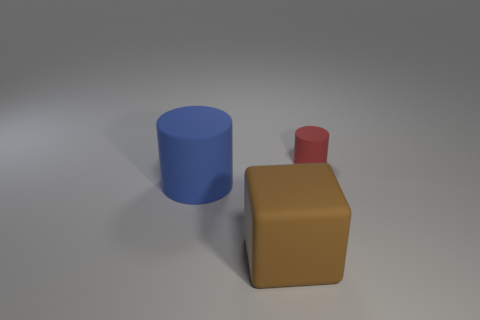What size is the rubber cylinder that is in front of the cylinder behind the big rubber object behind the block?
Give a very brief answer. Large. What number of small things are in front of the matte cylinder that is left of the tiny matte cylinder?
Ensure brevity in your answer.  0. What is the color of the other small thing that is made of the same material as the brown object?
Ensure brevity in your answer.  Red. There is a brown rubber thing that is the same size as the blue cylinder; what shape is it?
Your answer should be compact. Cube. Is the material of the large blue thing the same as the cylinder that is right of the large brown block?
Your answer should be compact. Yes. What number of other objects are there of the same material as the big block?
Keep it short and to the point. 2. There is a cylinder behind the rubber object on the left side of the big brown object; what number of small red rubber things are to the left of it?
Provide a succinct answer. 0. Does the matte thing behind the big rubber cylinder have the same shape as the blue rubber thing?
Provide a short and direct response. Yes. There is a cylinder on the right side of the blue matte cylinder; what material is it?
Keep it short and to the point. Rubber. The object that is both behind the large brown block and in front of the small red thing has what shape?
Ensure brevity in your answer.  Cylinder. 